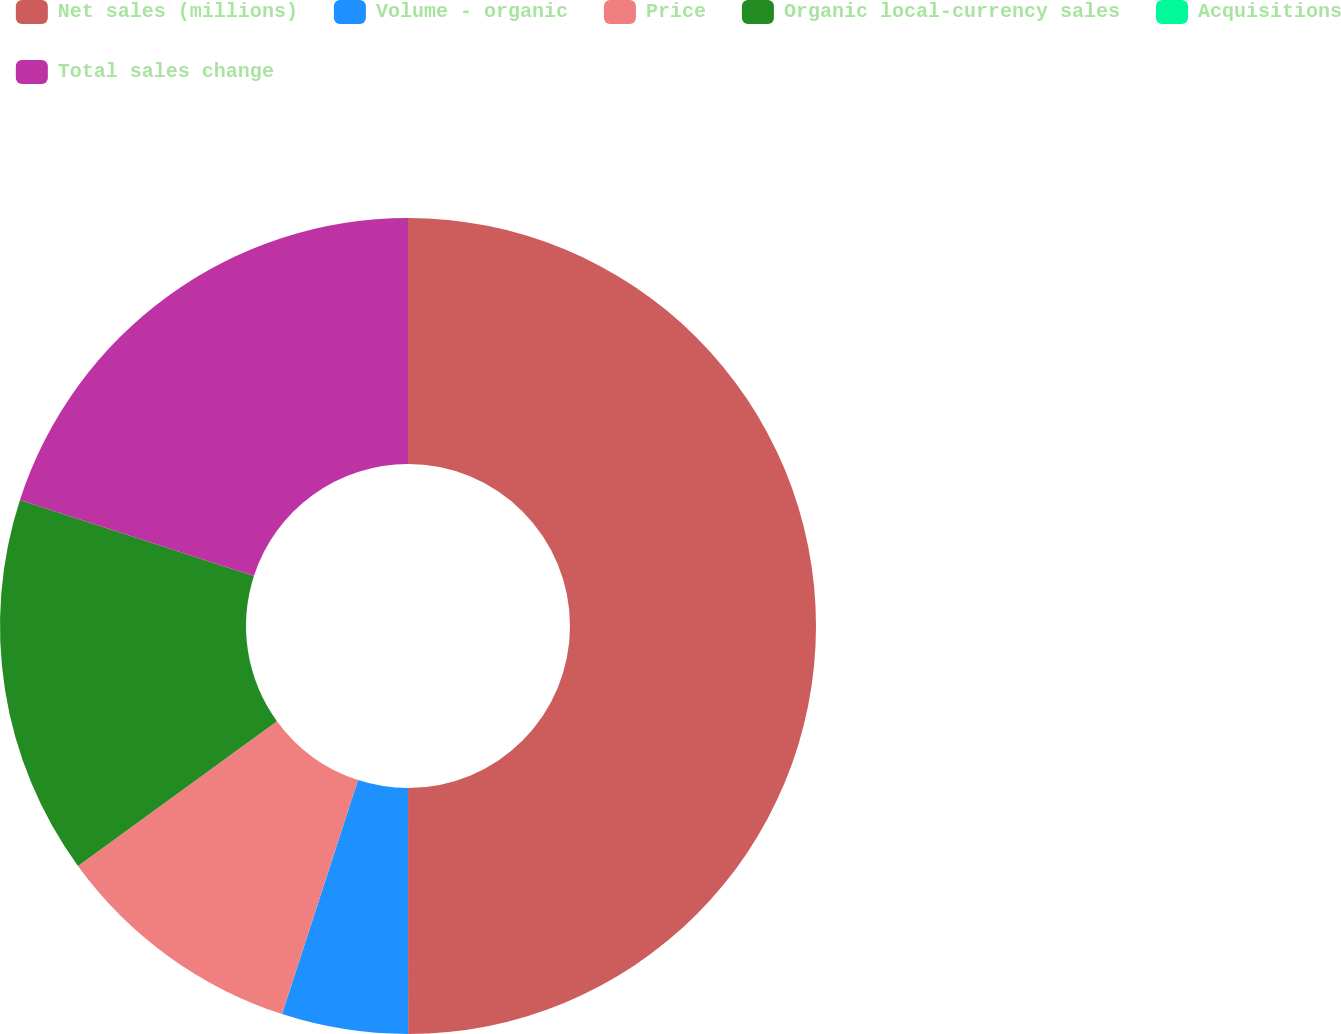Convert chart. <chart><loc_0><loc_0><loc_500><loc_500><pie_chart><fcel>Net sales (millions)<fcel>Volume - organic<fcel>Price<fcel>Organic local-currency sales<fcel>Acquisitions<fcel>Total sales change<nl><fcel>49.99%<fcel>5.0%<fcel>10.0%<fcel>15.0%<fcel>0.0%<fcel>20.0%<nl></chart> 